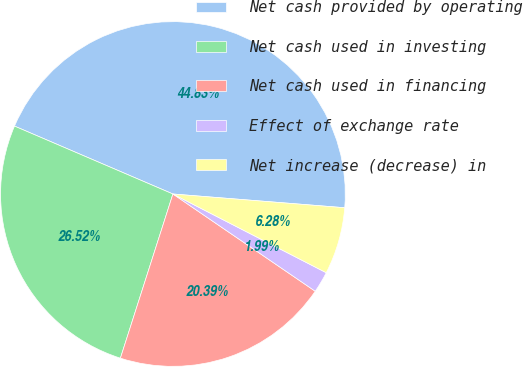Convert chart. <chart><loc_0><loc_0><loc_500><loc_500><pie_chart><fcel>Net cash provided by operating<fcel>Net cash used in investing<fcel>Net cash used in financing<fcel>Effect of exchange rate<fcel>Net increase (decrease) in<nl><fcel>44.83%<fcel>26.52%<fcel>20.39%<fcel>1.99%<fcel>6.28%<nl></chart> 